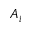<formula> <loc_0><loc_0><loc_500><loc_500>A _ { i }</formula> 